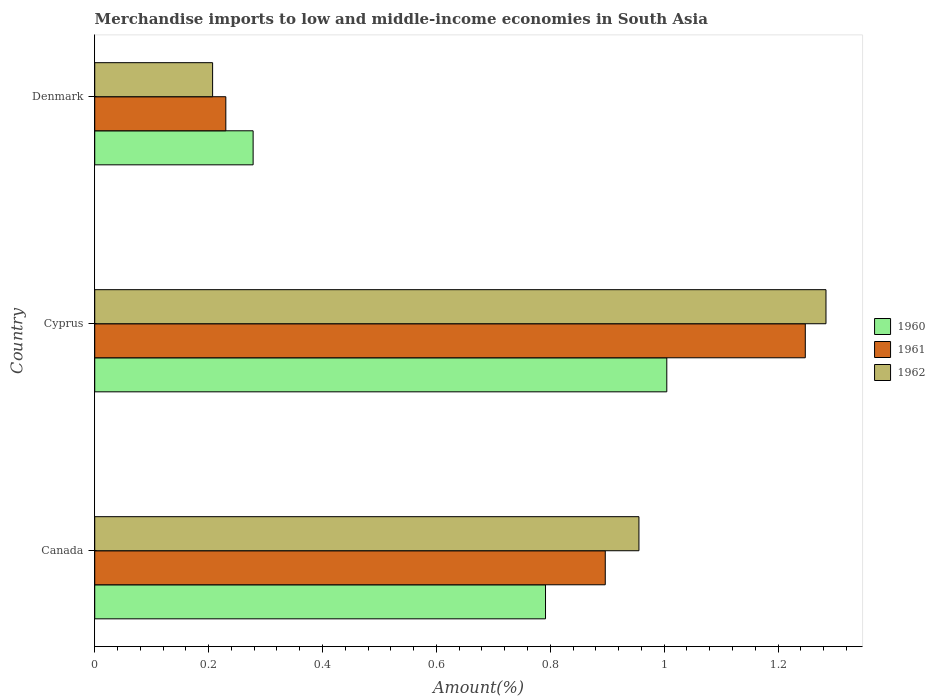How many different coloured bars are there?
Make the answer very short. 3. What is the label of the 2nd group of bars from the top?
Your response must be concise. Cyprus. In how many cases, is the number of bars for a given country not equal to the number of legend labels?
Offer a terse response. 0. What is the percentage of amount earned from merchandise imports in 1961 in Canada?
Give a very brief answer. 0.9. Across all countries, what is the maximum percentage of amount earned from merchandise imports in 1961?
Provide a succinct answer. 1.25. Across all countries, what is the minimum percentage of amount earned from merchandise imports in 1962?
Make the answer very short. 0.21. In which country was the percentage of amount earned from merchandise imports in 1961 maximum?
Your answer should be very brief. Cyprus. In which country was the percentage of amount earned from merchandise imports in 1961 minimum?
Offer a very short reply. Denmark. What is the total percentage of amount earned from merchandise imports in 1962 in the graph?
Make the answer very short. 2.45. What is the difference between the percentage of amount earned from merchandise imports in 1960 in Cyprus and that in Denmark?
Provide a succinct answer. 0.73. What is the difference between the percentage of amount earned from merchandise imports in 1960 in Denmark and the percentage of amount earned from merchandise imports in 1962 in Cyprus?
Provide a short and direct response. -1.01. What is the average percentage of amount earned from merchandise imports in 1962 per country?
Give a very brief answer. 0.82. What is the difference between the percentage of amount earned from merchandise imports in 1962 and percentage of amount earned from merchandise imports in 1961 in Canada?
Give a very brief answer. 0.06. What is the ratio of the percentage of amount earned from merchandise imports in 1961 in Canada to that in Denmark?
Your answer should be very brief. 3.89. Is the difference between the percentage of amount earned from merchandise imports in 1962 in Canada and Denmark greater than the difference between the percentage of amount earned from merchandise imports in 1961 in Canada and Denmark?
Ensure brevity in your answer.  Yes. What is the difference between the highest and the second highest percentage of amount earned from merchandise imports in 1961?
Make the answer very short. 0.35. What is the difference between the highest and the lowest percentage of amount earned from merchandise imports in 1961?
Your answer should be very brief. 1.02. Is the sum of the percentage of amount earned from merchandise imports in 1960 in Canada and Cyprus greater than the maximum percentage of amount earned from merchandise imports in 1962 across all countries?
Ensure brevity in your answer.  Yes. Is it the case that in every country, the sum of the percentage of amount earned from merchandise imports in 1962 and percentage of amount earned from merchandise imports in 1961 is greater than the percentage of amount earned from merchandise imports in 1960?
Provide a succinct answer. Yes. How many bars are there?
Provide a succinct answer. 9. Are all the bars in the graph horizontal?
Make the answer very short. Yes. How many legend labels are there?
Your response must be concise. 3. What is the title of the graph?
Your answer should be compact. Merchandise imports to low and middle-income economies in South Asia. What is the label or title of the X-axis?
Your answer should be very brief. Amount(%). What is the Amount(%) of 1960 in Canada?
Provide a succinct answer. 0.79. What is the Amount(%) of 1961 in Canada?
Provide a succinct answer. 0.9. What is the Amount(%) in 1962 in Canada?
Ensure brevity in your answer.  0.96. What is the Amount(%) in 1960 in Cyprus?
Ensure brevity in your answer.  1. What is the Amount(%) in 1961 in Cyprus?
Your response must be concise. 1.25. What is the Amount(%) in 1962 in Cyprus?
Offer a terse response. 1.28. What is the Amount(%) of 1960 in Denmark?
Provide a short and direct response. 0.28. What is the Amount(%) in 1961 in Denmark?
Your answer should be very brief. 0.23. What is the Amount(%) of 1962 in Denmark?
Offer a very short reply. 0.21. Across all countries, what is the maximum Amount(%) in 1960?
Keep it short and to the point. 1. Across all countries, what is the maximum Amount(%) in 1961?
Provide a succinct answer. 1.25. Across all countries, what is the maximum Amount(%) of 1962?
Provide a short and direct response. 1.28. Across all countries, what is the minimum Amount(%) in 1960?
Keep it short and to the point. 0.28. Across all countries, what is the minimum Amount(%) in 1961?
Offer a terse response. 0.23. Across all countries, what is the minimum Amount(%) in 1962?
Your answer should be very brief. 0.21. What is the total Amount(%) in 1960 in the graph?
Make the answer very short. 2.07. What is the total Amount(%) of 1961 in the graph?
Make the answer very short. 2.37. What is the total Amount(%) in 1962 in the graph?
Your answer should be compact. 2.45. What is the difference between the Amount(%) in 1960 in Canada and that in Cyprus?
Your answer should be compact. -0.21. What is the difference between the Amount(%) in 1961 in Canada and that in Cyprus?
Your answer should be very brief. -0.35. What is the difference between the Amount(%) in 1962 in Canada and that in Cyprus?
Provide a succinct answer. -0.33. What is the difference between the Amount(%) of 1960 in Canada and that in Denmark?
Your answer should be compact. 0.51. What is the difference between the Amount(%) of 1961 in Canada and that in Denmark?
Offer a very short reply. 0.67. What is the difference between the Amount(%) of 1962 in Canada and that in Denmark?
Offer a terse response. 0.75. What is the difference between the Amount(%) in 1960 in Cyprus and that in Denmark?
Offer a very short reply. 0.73. What is the difference between the Amount(%) in 1961 in Cyprus and that in Denmark?
Your answer should be very brief. 1.02. What is the difference between the Amount(%) in 1962 in Cyprus and that in Denmark?
Keep it short and to the point. 1.08. What is the difference between the Amount(%) of 1960 in Canada and the Amount(%) of 1961 in Cyprus?
Give a very brief answer. -0.46. What is the difference between the Amount(%) in 1960 in Canada and the Amount(%) in 1962 in Cyprus?
Your answer should be very brief. -0.49. What is the difference between the Amount(%) of 1961 in Canada and the Amount(%) of 1962 in Cyprus?
Provide a succinct answer. -0.39. What is the difference between the Amount(%) of 1960 in Canada and the Amount(%) of 1961 in Denmark?
Offer a very short reply. 0.56. What is the difference between the Amount(%) of 1960 in Canada and the Amount(%) of 1962 in Denmark?
Your response must be concise. 0.58. What is the difference between the Amount(%) in 1961 in Canada and the Amount(%) in 1962 in Denmark?
Your answer should be compact. 0.69. What is the difference between the Amount(%) of 1960 in Cyprus and the Amount(%) of 1961 in Denmark?
Keep it short and to the point. 0.77. What is the difference between the Amount(%) in 1960 in Cyprus and the Amount(%) in 1962 in Denmark?
Provide a short and direct response. 0.8. What is the difference between the Amount(%) of 1961 in Cyprus and the Amount(%) of 1962 in Denmark?
Your answer should be very brief. 1.04. What is the average Amount(%) in 1960 per country?
Provide a short and direct response. 0.69. What is the average Amount(%) of 1961 per country?
Your answer should be very brief. 0.79. What is the average Amount(%) in 1962 per country?
Make the answer very short. 0.82. What is the difference between the Amount(%) of 1960 and Amount(%) of 1961 in Canada?
Offer a terse response. -0.1. What is the difference between the Amount(%) of 1960 and Amount(%) of 1962 in Canada?
Your response must be concise. -0.16. What is the difference between the Amount(%) of 1961 and Amount(%) of 1962 in Canada?
Give a very brief answer. -0.06. What is the difference between the Amount(%) in 1960 and Amount(%) in 1961 in Cyprus?
Your answer should be compact. -0.24. What is the difference between the Amount(%) in 1960 and Amount(%) in 1962 in Cyprus?
Ensure brevity in your answer.  -0.28. What is the difference between the Amount(%) in 1961 and Amount(%) in 1962 in Cyprus?
Make the answer very short. -0.04. What is the difference between the Amount(%) in 1960 and Amount(%) in 1961 in Denmark?
Offer a very short reply. 0.05. What is the difference between the Amount(%) in 1960 and Amount(%) in 1962 in Denmark?
Make the answer very short. 0.07. What is the difference between the Amount(%) in 1961 and Amount(%) in 1962 in Denmark?
Your answer should be compact. 0.02. What is the ratio of the Amount(%) of 1960 in Canada to that in Cyprus?
Give a very brief answer. 0.79. What is the ratio of the Amount(%) in 1961 in Canada to that in Cyprus?
Give a very brief answer. 0.72. What is the ratio of the Amount(%) in 1962 in Canada to that in Cyprus?
Ensure brevity in your answer.  0.74. What is the ratio of the Amount(%) in 1960 in Canada to that in Denmark?
Your answer should be compact. 2.85. What is the ratio of the Amount(%) of 1961 in Canada to that in Denmark?
Offer a very short reply. 3.89. What is the ratio of the Amount(%) of 1962 in Canada to that in Denmark?
Provide a short and direct response. 4.62. What is the ratio of the Amount(%) in 1960 in Cyprus to that in Denmark?
Provide a succinct answer. 3.61. What is the ratio of the Amount(%) of 1961 in Cyprus to that in Denmark?
Your answer should be very brief. 5.42. What is the ratio of the Amount(%) of 1962 in Cyprus to that in Denmark?
Ensure brevity in your answer.  6.2. What is the difference between the highest and the second highest Amount(%) in 1960?
Your answer should be very brief. 0.21. What is the difference between the highest and the second highest Amount(%) in 1961?
Your answer should be very brief. 0.35. What is the difference between the highest and the second highest Amount(%) in 1962?
Offer a terse response. 0.33. What is the difference between the highest and the lowest Amount(%) of 1960?
Offer a terse response. 0.73. What is the difference between the highest and the lowest Amount(%) in 1961?
Ensure brevity in your answer.  1.02. What is the difference between the highest and the lowest Amount(%) of 1962?
Offer a terse response. 1.08. 